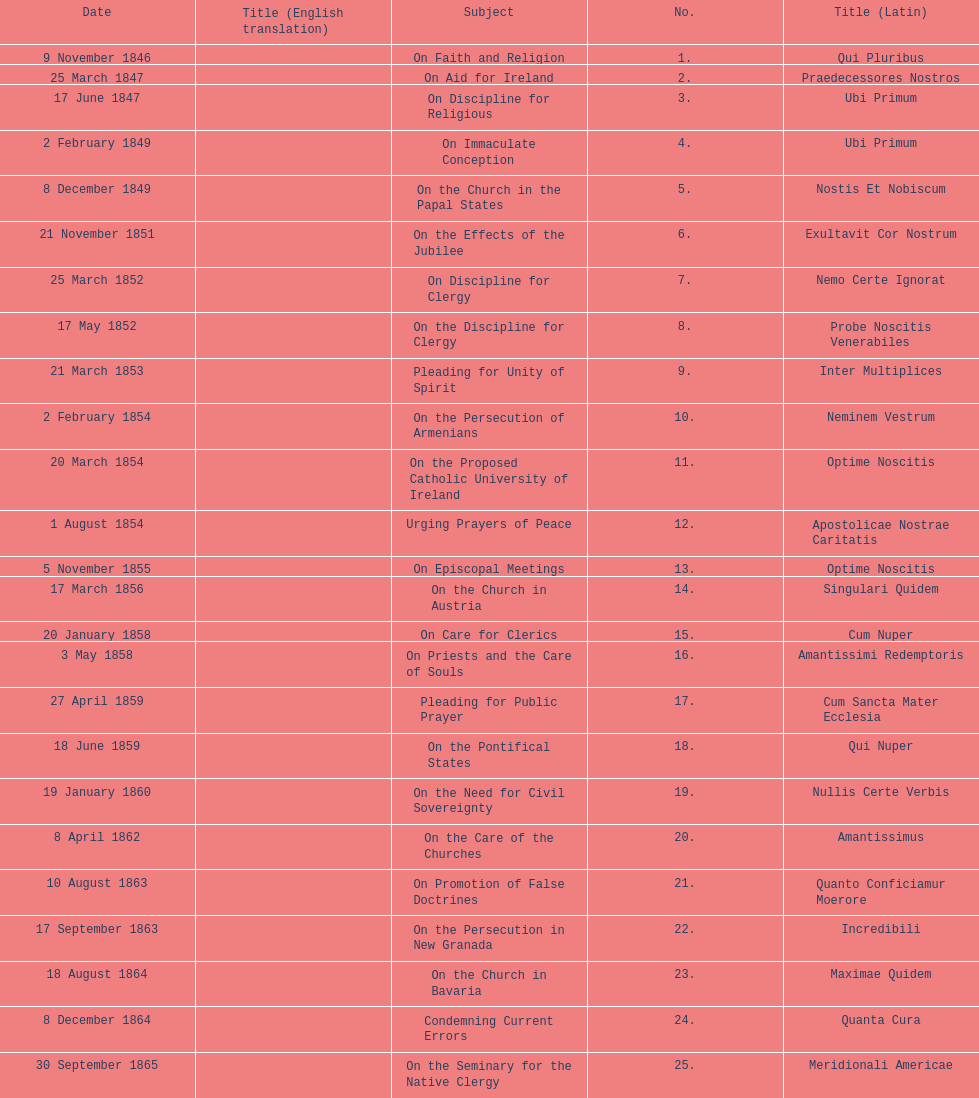In the first 10 years of his reign, how many encyclicals did pope pius ix issue? 14. 